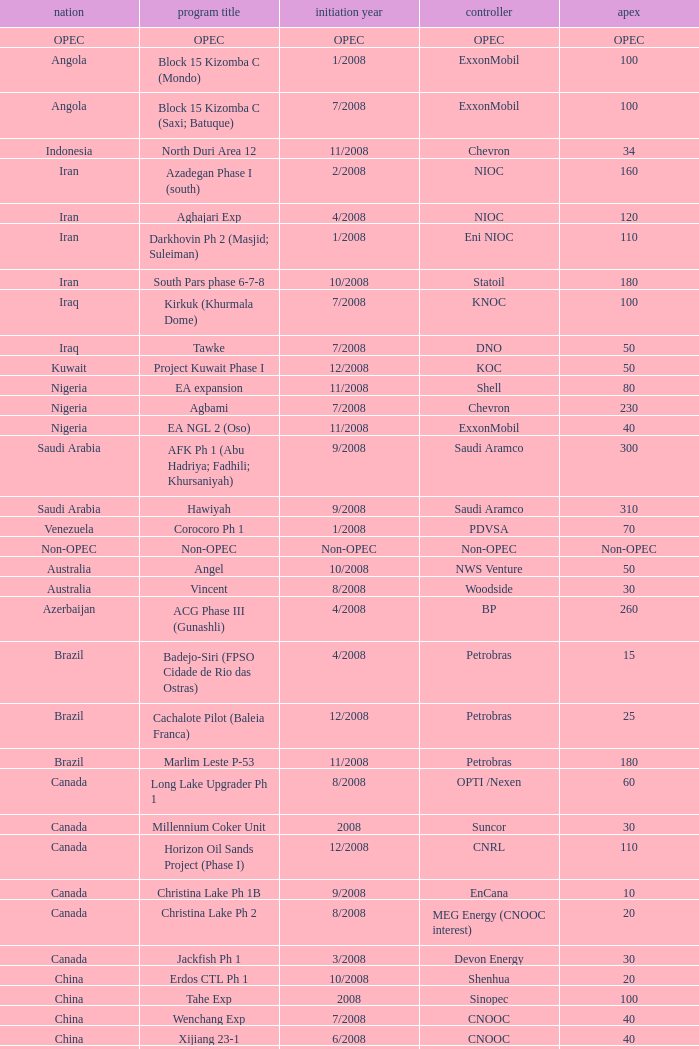What is the Project Name with a Country that is opec? OPEC. 